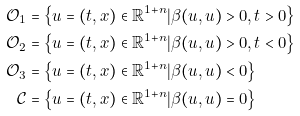<formula> <loc_0><loc_0><loc_500><loc_500>\mathcal { O } _ { 1 } & = \left \{ u = ( t , x ) \in \mathbb { R } ^ { 1 + n } | \beta ( u , u ) > 0 , t > 0 \right \} \\ \mathcal { O } _ { 2 } & = \left \{ u = ( t , x ) \in \mathbb { R } ^ { 1 + n } | \beta ( u , u ) > 0 , t < 0 \right \} \\ \mathcal { O } _ { 3 } & = \left \{ u = ( t , x ) \in \mathbb { R } ^ { 1 + n } | \beta ( u , u ) < 0 \right \} \\ \mathcal { C } & = \left \{ u = ( t , x ) \in \mathbb { R } ^ { 1 + n } | \beta ( u , u ) = 0 \right \}</formula> 